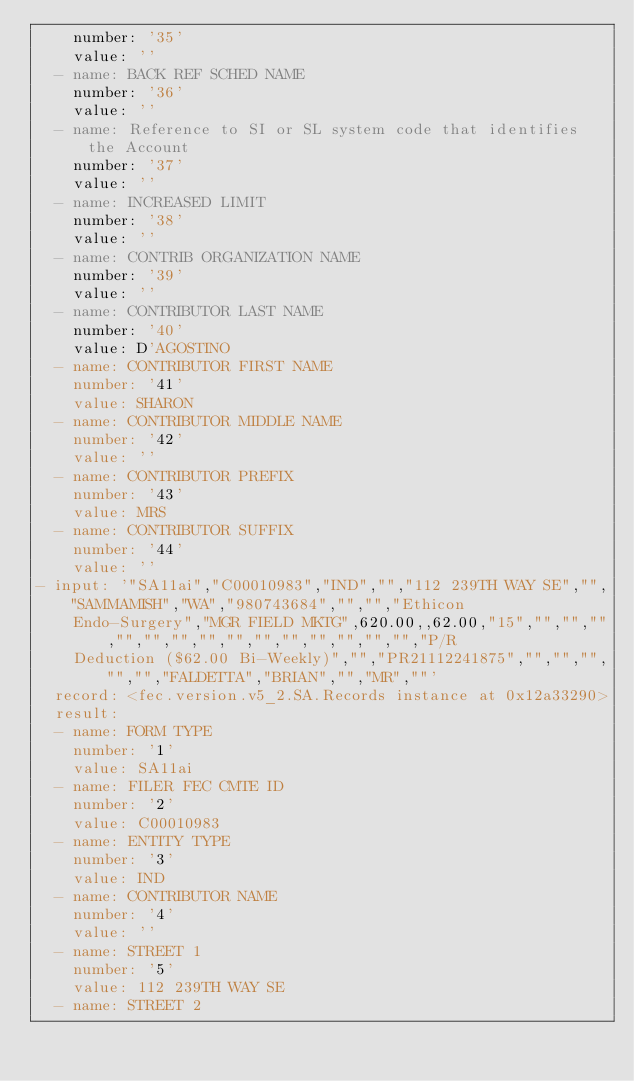<code> <loc_0><loc_0><loc_500><loc_500><_YAML_>    number: '35'
    value: ''
  - name: BACK REF SCHED NAME
    number: '36'
    value: ''
  - name: Reference to SI or SL system code that identifies the Account
    number: '37'
    value: ''
  - name: INCREASED LIMIT
    number: '38'
    value: ''
  - name: CONTRIB ORGANIZATION NAME
    number: '39'
    value: ''
  - name: CONTRIBUTOR LAST NAME
    number: '40'
    value: D'AGOSTINO
  - name: CONTRIBUTOR FIRST NAME
    number: '41'
    value: SHARON
  - name: CONTRIBUTOR MIDDLE NAME
    number: '42'
    value: ''
  - name: CONTRIBUTOR PREFIX
    number: '43'
    value: MRS
  - name: CONTRIBUTOR SUFFIX
    number: '44'
    value: ''
- input: '"SA11ai","C00010983","IND","","112 239TH WAY SE","","SAMMAMISH","WA","980743684","","","Ethicon
    Endo-Surgery","MGR FIELD MKTG",620.00,,62.00,"15","","","","","","","","","","","","","","","P/R
    Deduction ($62.00 Bi-Weekly)","","PR21112241875","","","","","","FALDETTA","BRIAN","","MR",""'
  record: <fec.version.v5_2.SA.Records instance at 0x12a33290>
  result:
  - name: FORM TYPE
    number: '1'
    value: SA11ai
  - name: FILER FEC CMTE ID
    number: '2'
    value: C00010983
  - name: ENTITY TYPE
    number: '3'
    value: IND
  - name: CONTRIBUTOR NAME
    number: '4'
    value: ''
  - name: STREET 1
    number: '5'
    value: 112 239TH WAY SE
  - name: STREET 2</code> 